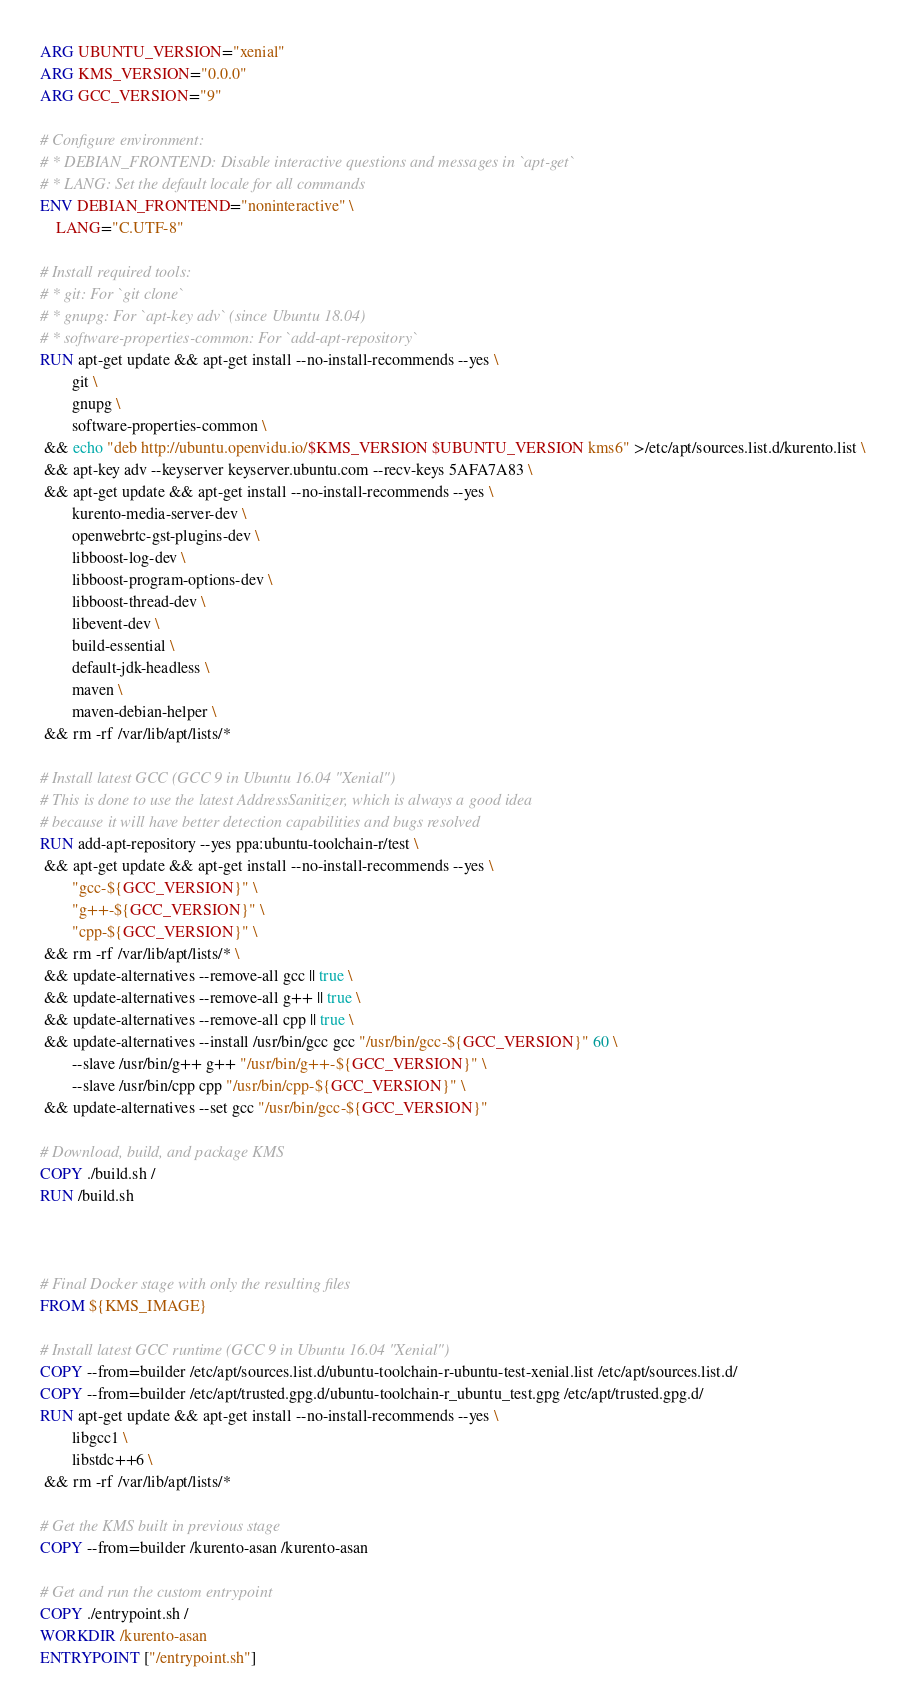Convert code to text. <code><loc_0><loc_0><loc_500><loc_500><_Dockerfile_>ARG UBUNTU_VERSION="xenial"
ARG KMS_VERSION="0.0.0"
ARG GCC_VERSION="9"

# Configure environment:
# * DEBIAN_FRONTEND: Disable interactive questions and messages in `apt-get`
# * LANG: Set the default locale for all commands
ENV DEBIAN_FRONTEND="noninteractive" \
    LANG="C.UTF-8"

# Install required tools:
# * git: For `git clone`
# * gnupg: For `apt-key adv` (since Ubuntu 18.04)
# * software-properties-common: For `add-apt-repository`
RUN apt-get update && apt-get install --no-install-recommends --yes \
        git \
        gnupg \
        software-properties-common \
 && echo "deb http://ubuntu.openvidu.io/$KMS_VERSION $UBUNTU_VERSION kms6" >/etc/apt/sources.list.d/kurento.list \
 && apt-key adv --keyserver keyserver.ubuntu.com --recv-keys 5AFA7A83 \
 && apt-get update && apt-get install --no-install-recommends --yes \
        kurento-media-server-dev \
        openwebrtc-gst-plugins-dev \
        libboost-log-dev \
        libboost-program-options-dev \
        libboost-thread-dev \
        libevent-dev \
        build-essential \
        default-jdk-headless \
        maven \
        maven-debian-helper \
 && rm -rf /var/lib/apt/lists/*

# Install latest GCC (GCC 9 in Ubuntu 16.04 "Xenial")
# This is done to use the latest AddressSanitizer, which is always a good idea
# because it will have better detection capabilities and bugs resolved
RUN add-apt-repository --yes ppa:ubuntu-toolchain-r/test \
 && apt-get update && apt-get install --no-install-recommends --yes \
        "gcc-${GCC_VERSION}" \
        "g++-${GCC_VERSION}" \
        "cpp-${GCC_VERSION}" \
 && rm -rf /var/lib/apt/lists/* \
 && update-alternatives --remove-all gcc || true \
 && update-alternatives --remove-all g++ || true \
 && update-alternatives --remove-all cpp || true \
 && update-alternatives --install /usr/bin/gcc gcc "/usr/bin/gcc-${GCC_VERSION}" 60 \
        --slave /usr/bin/g++ g++ "/usr/bin/g++-${GCC_VERSION}" \
        --slave /usr/bin/cpp cpp "/usr/bin/cpp-${GCC_VERSION}" \
 && update-alternatives --set gcc "/usr/bin/gcc-${GCC_VERSION}"

# Download, build, and package KMS
COPY ./build.sh /
RUN /build.sh



# Final Docker stage with only the resulting files
FROM ${KMS_IMAGE}

# Install latest GCC runtime (GCC 9 in Ubuntu 16.04 "Xenial")
COPY --from=builder /etc/apt/sources.list.d/ubuntu-toolchain-r-ubuntu-test-xenial.list /etc/apt/sources.list.d/
COPY --from=builder /etc/apt/trusted.gpg.d/ubuntu-toolchain-r_ubuntu_test.gpg /etc/apt/trusted.gpg.d/
RUN apt-get update && apt-get install --no-install-recommends --yes \
        libgcc1 \
        libstdc++6 \
 && rm -rf /var/lib/apt/lists/*

# Get the KMS built in previous stage
COPY --from=builder /kurento-asan /kurento-asan

# Get and run the custom entrypoint
COPY ./entrypoint.sh /
WORKDIR /kurento-asan
ENTRYPOINT ["/entrypoint.sh"]
</code> 